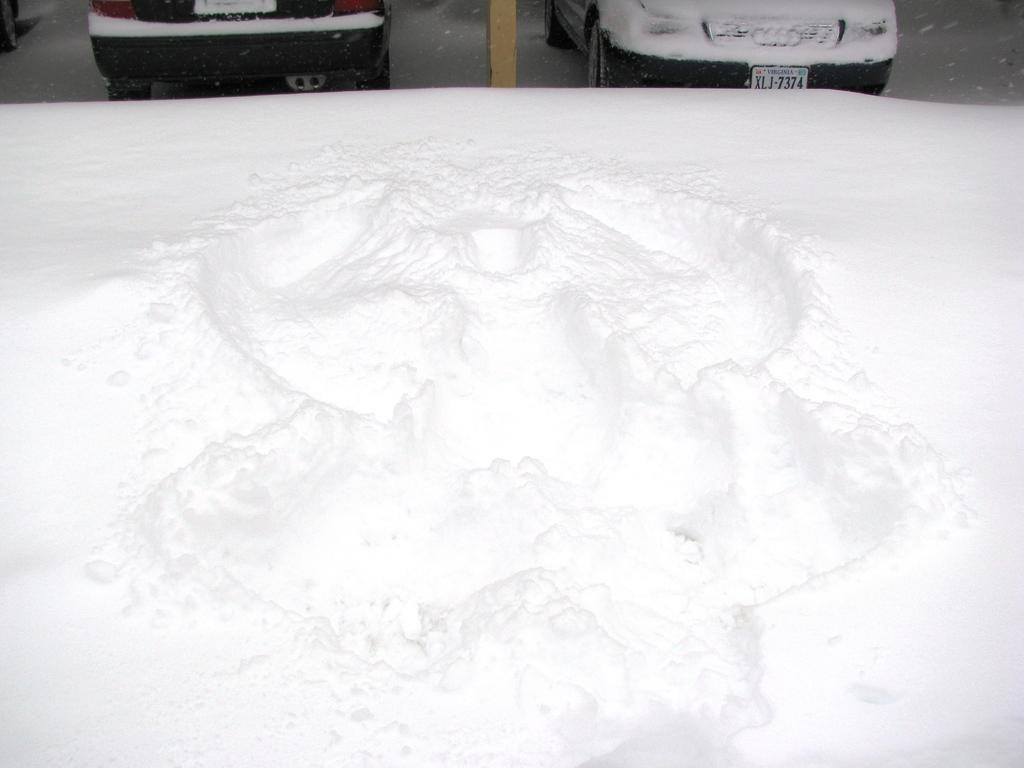Please provide a concise description of this image. In this picture there is snow in the center of the image and there are cars at the top side of the image. 